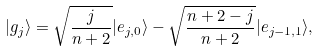<formula> <loc_0><loc_0><loc_500><loc_500>| g _ { j } \rangle = \sqrt { \frac { j } { n + 2 } } | e _ { j , 0 } \rangle - \sqrt { \frac { n + 2 - j } { n + 2 } } | e _ { j - 1 , 1 } \rangle ,</formula> 